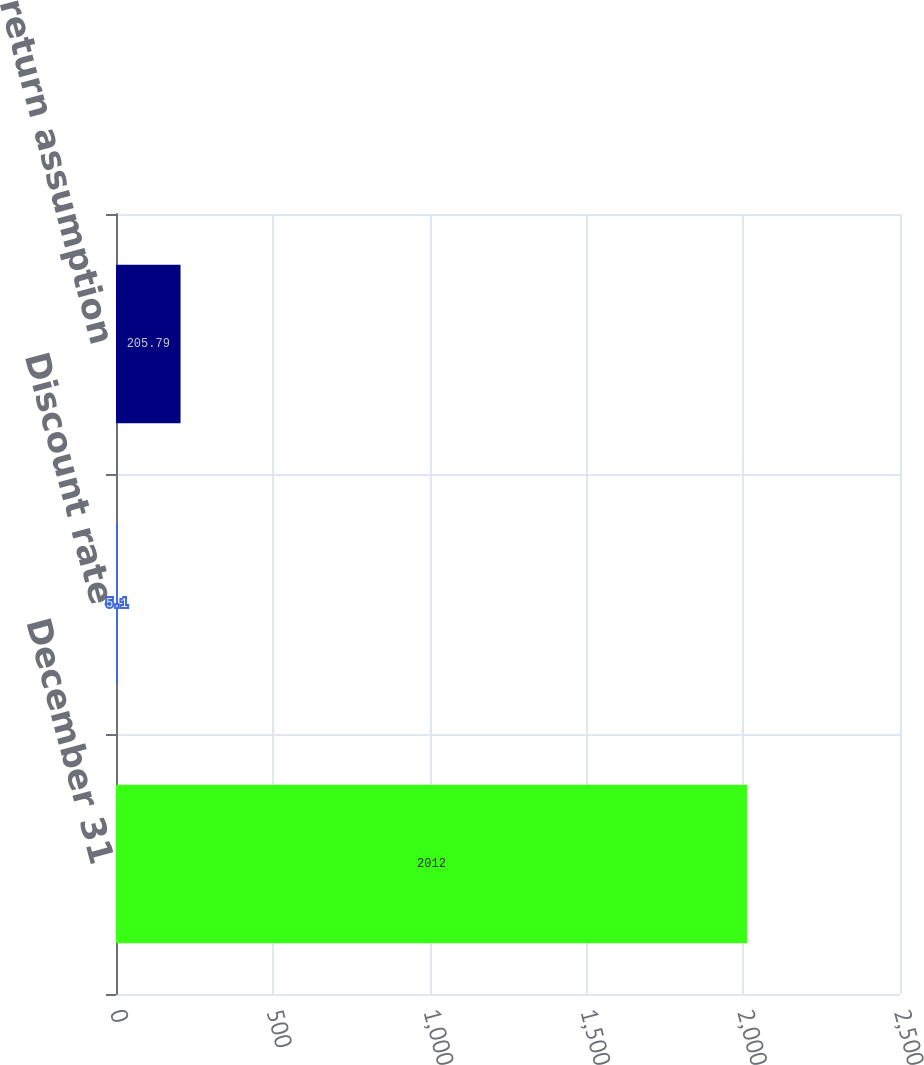<chart> <loc_0><loc_0><loc_500><loc_500><bar_chart><fcel>December 31<fcel>Discount rate<fcel>Investment return assumption<nl><fcel>2012<fcel>5.1<fcel>205.79<nl></chart> 